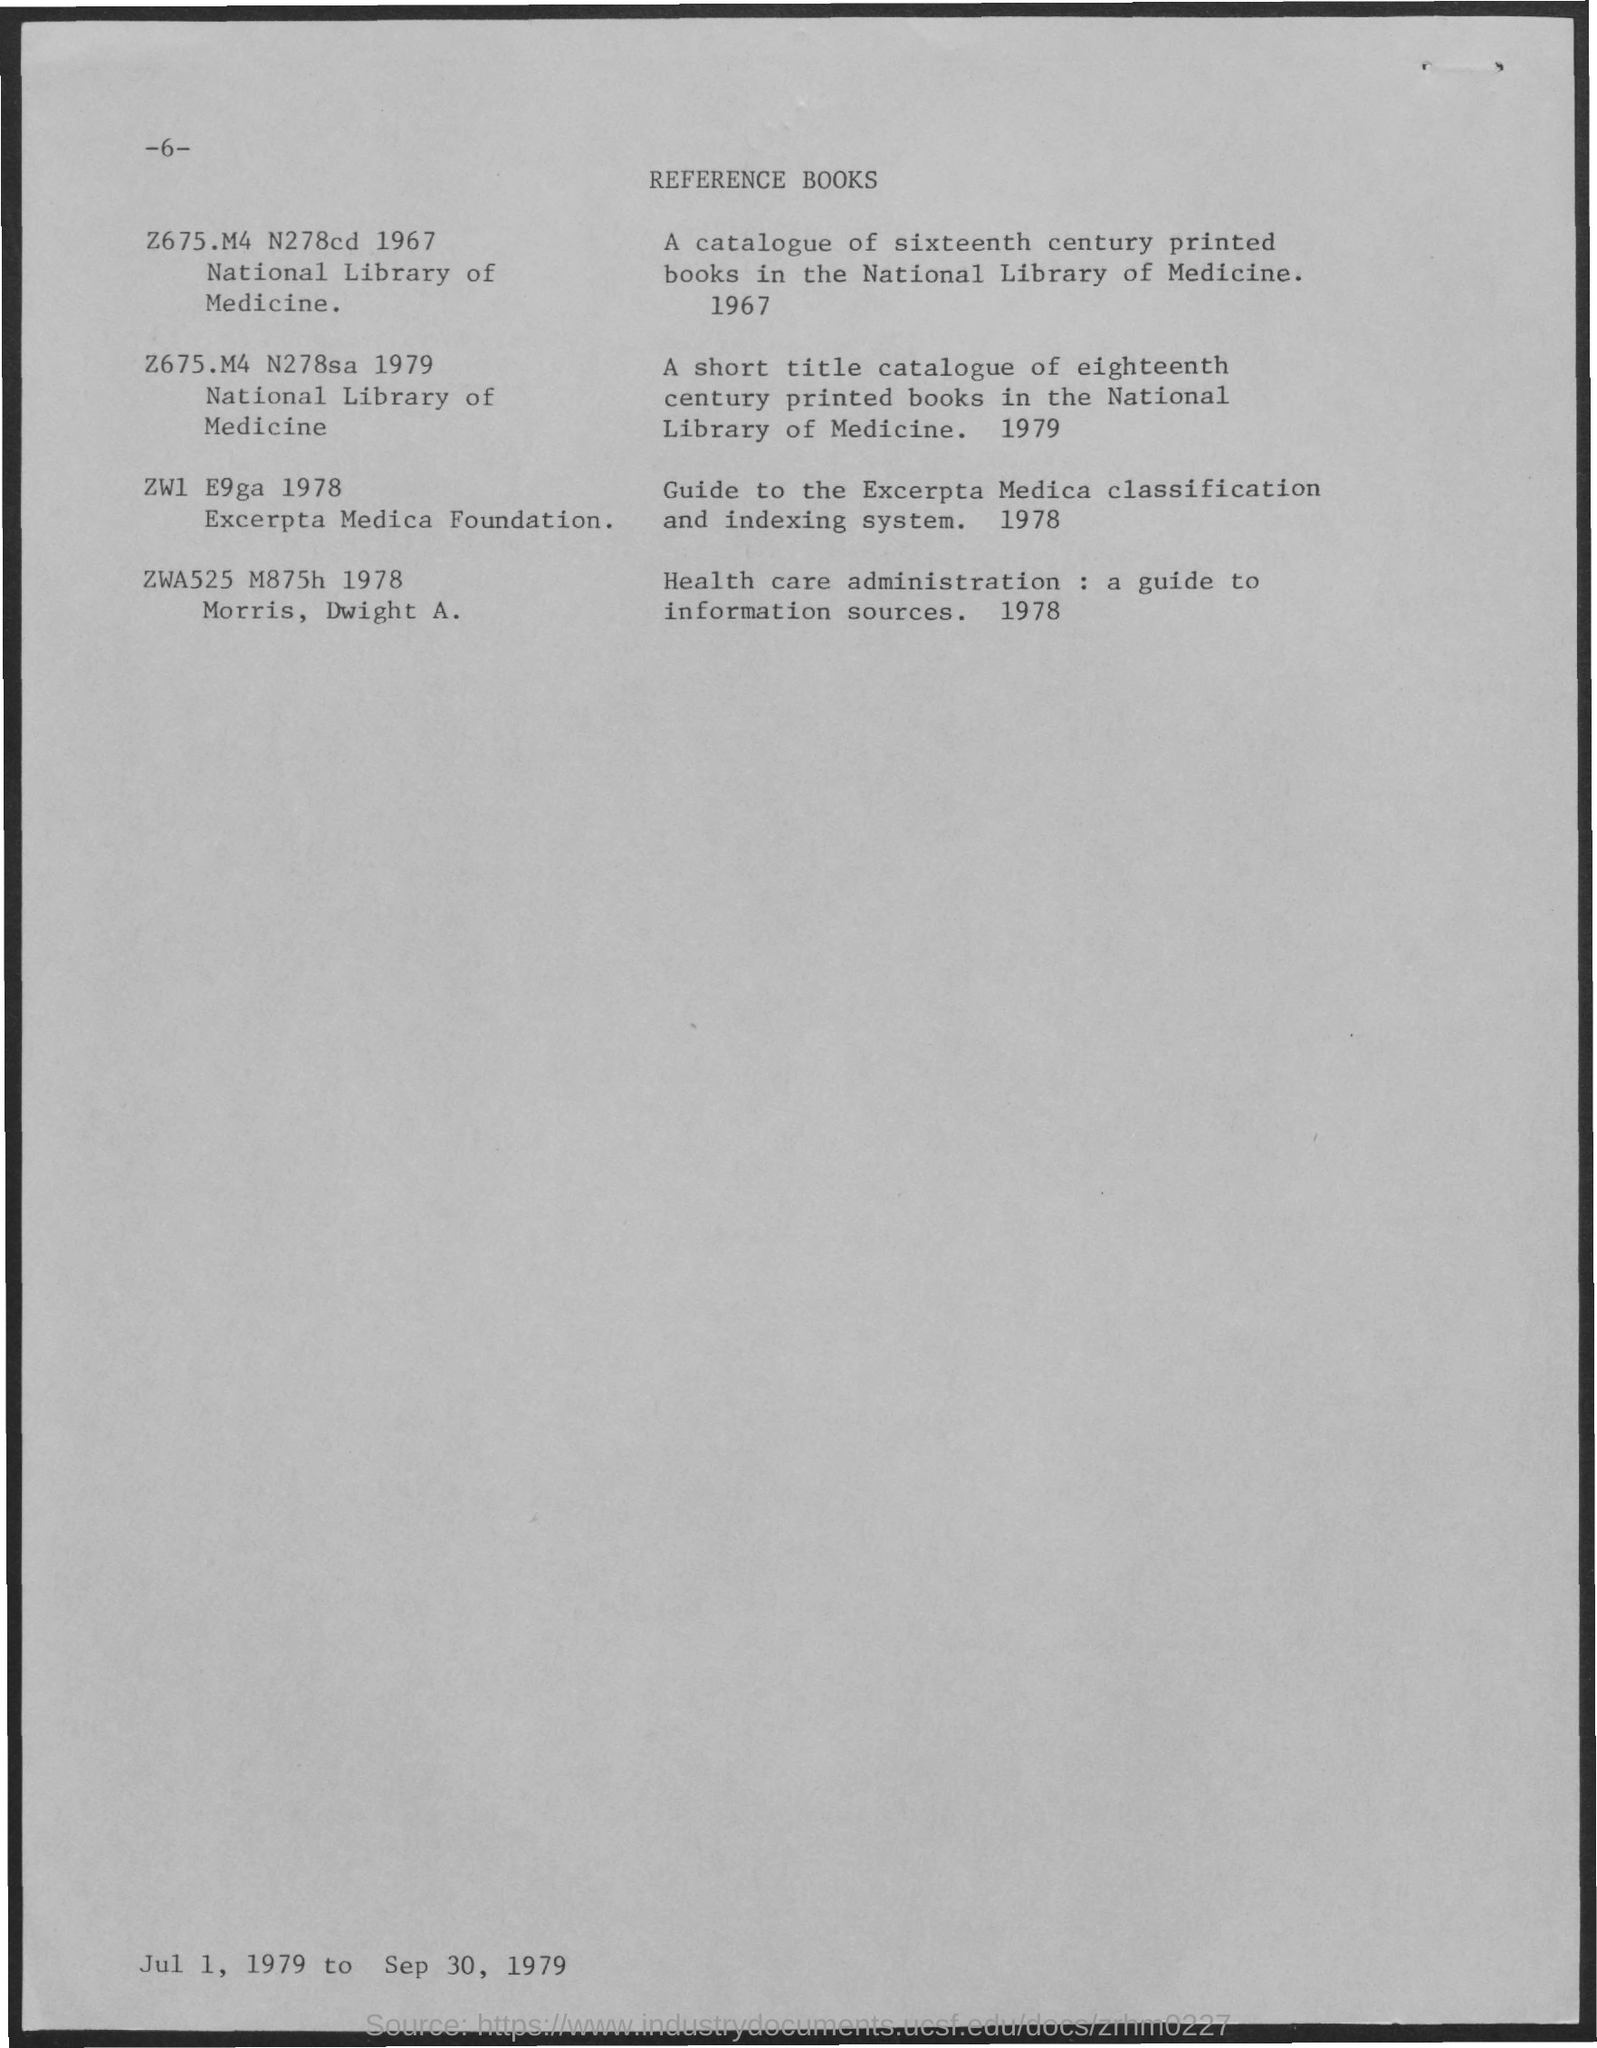What is the title of the document?
Make the answer very short. Reference books. What is the Page Number?
Keep it short and to the point. -6-. Health care administration: a guide to information sources is published in which year?
Make the answer very short. 1978. Guide to the Excerpta Media Classification and indexing system is published in which year?
Give a very brief answer. 1978. 